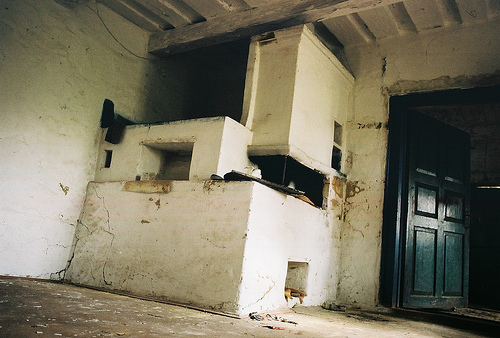<image>
Is the door to the right of the jamb? No. The door is not to the right of the jamb. The horizontal positioning shows a different relationship. 